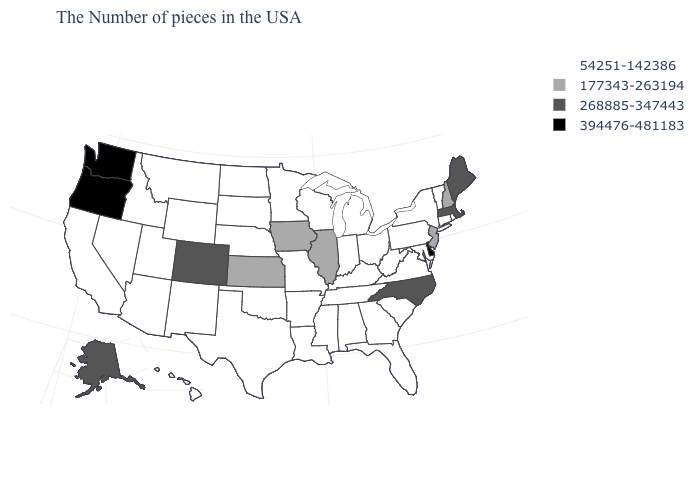What is the value of South Carolina?
Concise answer only. 54251-142386. How many symbols are there in the legend?
Give a very brief answer. 4. What is the lowest value in the USA?
Keep it brief. 54251-142386. Among the states that border Iowa , which have the highest value?
Write a very short answer. Illinois. What is the value of Kentucky?
Short answer required. 54251-142386. Name the states that have a value in the range 177343-263194?
Write a very short answer. New Hampshire, New Jersey, Illinois, Iowa, Kansas. What is the value of Oklahoma?
Give a very brief answer. 54251-142386. Name the states that have a value in the range 394476-481183?
Keep it brief. Delaware, Washington, Oregon. What is the highest value in the MidWest ?
Give a very brief answer. 177343-263194. Does Wisconsin have the highest value in the USA?
Be succinct. No. How many symbols are there in the legend?
Short answer required. 4. What is the value of Mississippi?
Write a very short answer. 54251-142386. What is the value of Oregon?
Be succinct. 394476-481183. What is the value of New Jersey?
Be succinct. 177343-263194. 